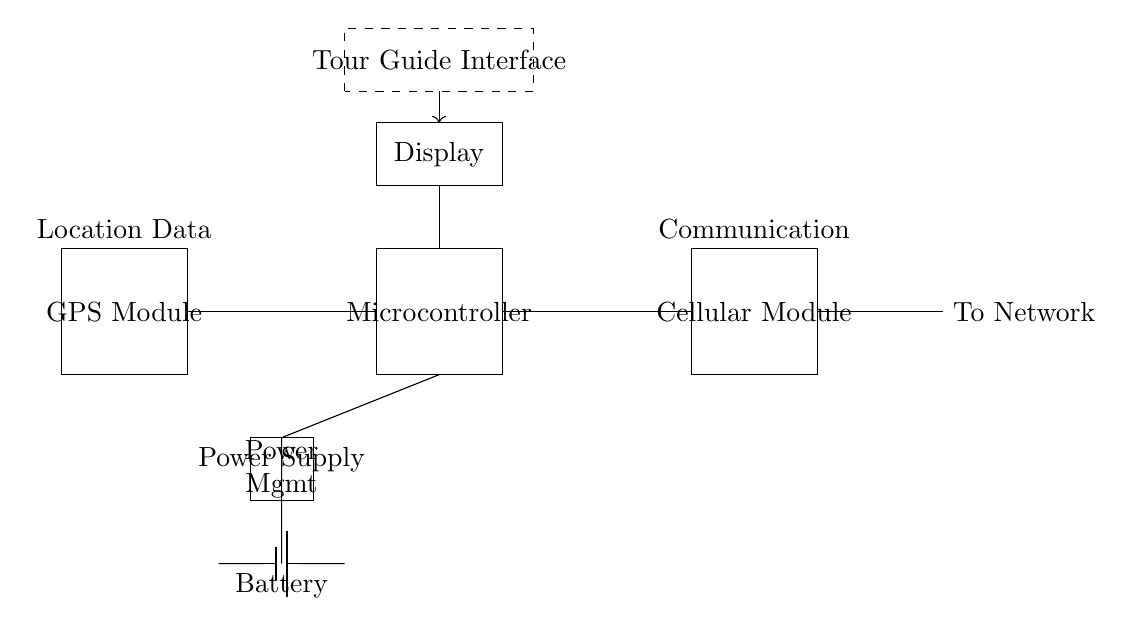What components are included in this circuit? The circuit comprises a GPS Module, Microcontroller, Battery, Cellular Module, Antenna, Display, Power Management, and a Tour Guide Interface.
Answer: GPS Module, Microcontroller, Battery, Cellular Module, Antenna, Display, Power Management, Tour Guide Interface What is the purpose of the Battery in this circuit? The Battery supplies power to the entire circuit, ensuring that all components, like the GPS module and Microcontroller, operate effectively.
Answer: Power supply How does the GPS Module connect to the Microcontroller? The GPS Module is connected to the Microcontroller through a direct line, indicating a data communication link for location information to be processed.
Answer: Direct connection What is the function of the Cellular Module in this circuit? The Cellular Module facilitates communication by sending GPS location data to a network, allowing for real-time tracking and updates during guided tours.
Answer: Enables communication Explain the relationship between the Power Management component and the Battery. The Power Management component regulates the power supplied from the Battery to other components, ensuring they receive appropriate voltage and current for operation.
Answer: Regulates power supply What type of communication is indicated by the Antenna in this circuit? The Antenna is associated with wireless communication, specifically for transmitting data from the Cellular Module to a network.
Answer: Wireless communication How does the Display interact with the Microcontroller? The Display receives data from the Microcontroller to present information relevant to the guided nature tour, such as location and connectivity status.
Answer: Data presentation 